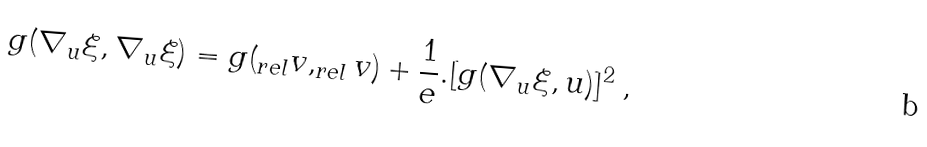<formula> <loc_0><loc_0><loc_500><loc_500>g ( \nabla _ { u } \xi , \nabla _ { u } \xi ) = g ( _ { r e l } v , _ { r e l } v ) + \frac { 1 } { e } . [ g ( \nabla _ { u } \xi , u ) ] ^ { 2 } \text { ,}</formula> 